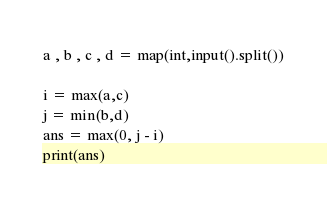Convert code to text. <code><loc_0><loc_0><loc_500><loc_500><_Python_>a , b , c , d = map(int,input().split())

i = max(a,c)
j = min(b,d)
ans = max(0, j - i)
print(ans)</code> 